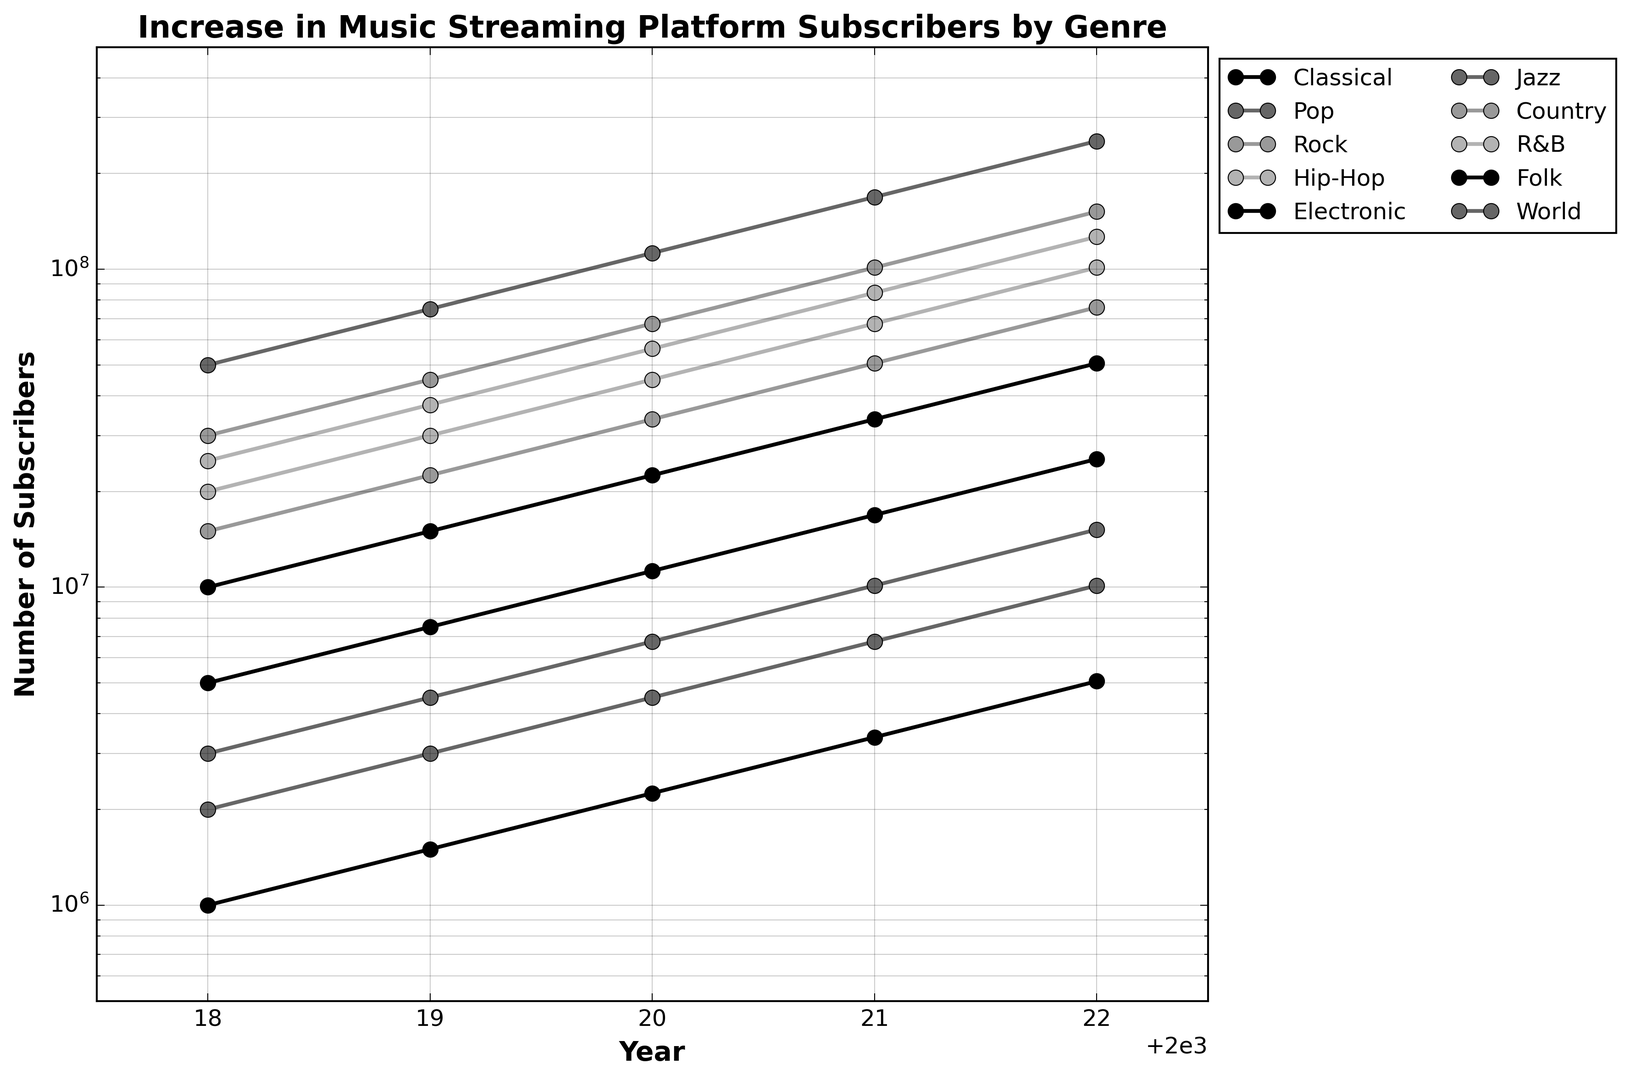What genre had the highest number of subscribers in 2022? Check the endpoint values for each genre in 2022; the genre with the highest value will be at the top of the vertical scale
Answer: Pop How many more subscribers did Pop have compared to Jazz in 2022? Subtract Jazz’s subscriber count from Pop's for the year 2022. 
Pop (253,125,000) - Jazz (10,125,000) = 243,000,000
Answer: 243,000,000 Which genre had the smallest growth between 2018 and 2022? Compare the distances between 2018 and 2022 points on the y-axis; the smallest visual difference represents the smallest growth. Classical appears to have the smallest visual slope
Answer: Jazz How did the subscriber count for R&B change from 2019 to 2021? Identify R&B values for 2019 (30,000,000) and 2021 (67,500,000) and compute the difference. 67,500,000 - 30,000,000 = 37,500,000
Answer: 37,500,000 Between Classical and Electronic music genres, which has shown a consistently higher number of subscribers from 2018 to 2022? Track the lines representing Classical and Electronic from 2018 to 2022. Classical consistently has higher values
Answer: Classical What is the approximate rate of growth for the Country genre from 2020 to 2022? Determine the subscriber counts for the Country genre in 2020 (33,750,000) and 2022 (75,937,500), then calculate the rate of growth
((75,937,500 - 33,750,000) / 33,750,000) * 100 ≈ 125
Answer: ≈ 125% Which genre experienced a more significant growth spurt between 2019 and 2020, Hip-Hop or Rock? Compare the steepness of the lines between 2019 and 2020 for Hip-Hop and Rock; steeper means higher growth
Answer: Rock Across all genres, which year saw the most significant change in subscriber numbers? Identify which year has the steepest overall lines across genres; check between years 2018, 2019, 2020, and 2021
Answer: 2020 What’s the difference in the median number of subscribers between Rock and World genres in 2022? Calculate the difference between their median values in 2022. Rock (151,875,000) - World (15,187,500)
Answer: 136,687,500 Based on the visual plot, which genre showed the most variability in annual growth rates? Visually check for the genre with the steepest and flattest lines across different years; that represents high variability
Answer: Jazz 